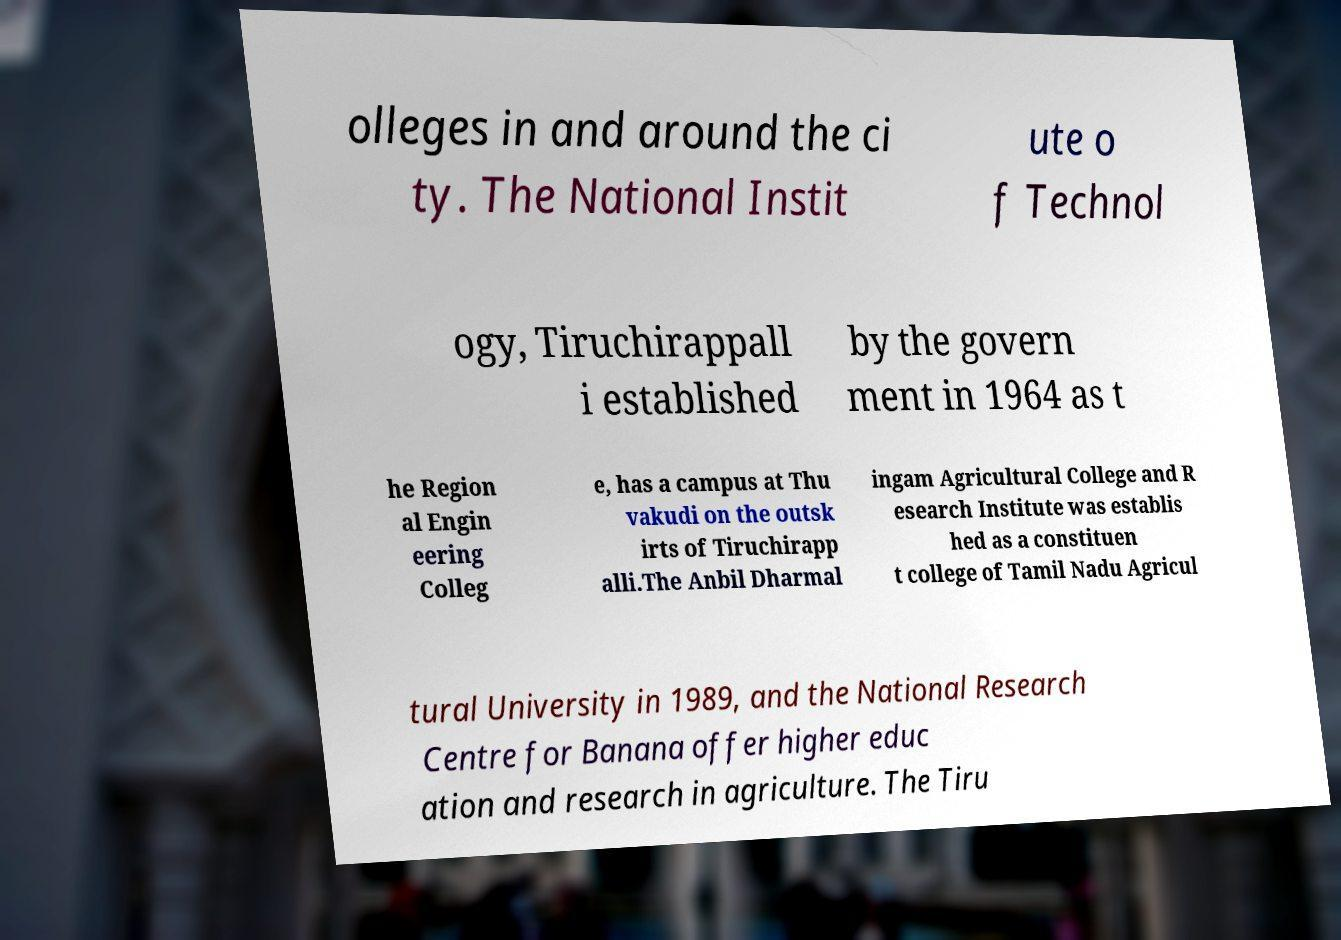There's text embedded in this image that I need extracted. Can you transcribe it verbatim? olleges in and around the ci ty. The National Instit ute o f Technol ogy, Tiruchirappall i established by the govern ment in 1964 as t he Region al Engin eering Colleg e, has a campus at Thu vakudi on the outsk irts of Tiruchirapp alli.The Anbil Dharmal ingam Agricultural College and R esearch Institute was establis hed as a constituen t college of Tamil Nadu Agricul tural University in 1989, and the National Research Centre for Banana offer higher educ ation and research in agriculture. The Tiru 